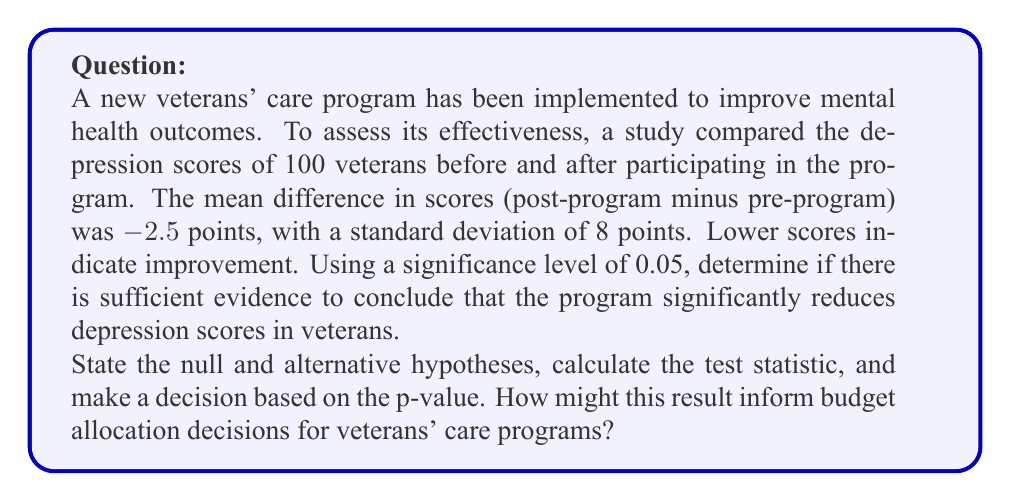Give your solution to this math problem. To solve this problem, we'll use a one-sample t-test since we're comparing the mean difference to a hypothesized value of 0 (no change).

1. State the hypotheses:
   $H_0: \mu_d = 0$ (null hypothesis: no change in depression scores)
   $H_a: \mu_d < 0$ (alternative hypothesis: depression scores decreased)

2. Calculate the test statistic:
   The formula for the t-statistic is:
   $$t = \frac{\bar{x} - \mu_0}{s / \sqrt{n}}$$
   
   Where:
   $\bar{x}$ = sample mean difference = -2.5
   $\mu_0$ = hypothesized population mean = 0
   $s$ = sample standard deviation = 8
   $n$ = sample size = 100

   Plugging in the values:
   $$t = \frac{-2.5 - 0}{8 / \sqrt{100}} = \frac{-2.5}{0.8} = -3.125$$

3. Calculate the degrees of freedom:
   $df = n - 1 = 100 - 1 = 99$

4. Find the p-value:
   Using a t-distribution table or calculator with 99 degrees of freedom and t = -3.125, we find:
   p-value ≈ 0.0011

5. Make a decision:
   Since the p-value (0.0011) is less than the significance level (0.05), we reject the null hypothesis.

6. Interpret the result:
   There is sufficient evidence to conclude that the veterans' care program significantly reduces depression scores in veterans.

This result suggests that the program is effective in improving mental health outcomes for veterans. From a budget perspective, this information could be used to justify continued or increased funding for the program, as it demonstrates a measurable benefit to veterans' wellbeing. However, a cost-benefit analysis would be necessary to determine if the program's effectiveness justifies its cost compared to other potential interventions or budget priorities.
Answer: Reject the null hypothesis. There is significant evidence (t = -3.125, p = 0.0011) that the veterans' care program reduces depression scores in veterans. This result supports the effectiveness of the program and could inform budget allocation decisions, but should be considered alongside cost-benefit analysis and other priorities. 